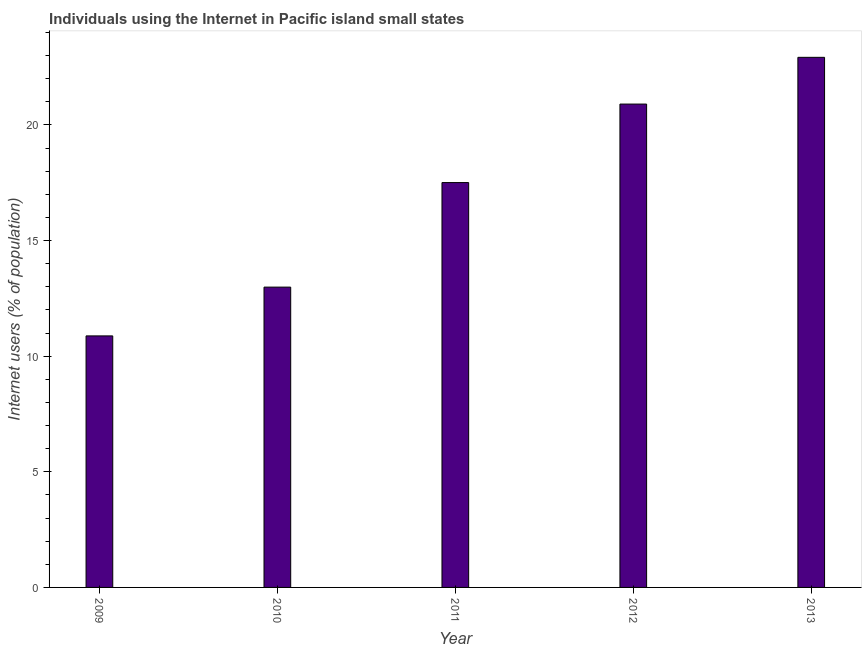Does the graph contain any zero values?
Make the answer very short. No. Does the graph contain grids?
Your response must be concise. No. What is the title of the graph?
Your answer should be very brief. Individuals using the Internet in Pacific island small states. What is the label or title of the X-axis?
Offer a terse response. Year. What is the label or title of the Y-axis?
Make the answer very short. Internet users (% of population). What is the number of internet users in 2009?
Provide a succinct answer. 10.88. Across all years, what is the maximum number of internet users?
Offer a terse response. 22.92. Across all years, what is the minimum number of internet users?
Ensure brevity in your answer.  10.88. What is the sum of the number of internet users?
Give a very brief answer. 85.2. What is the difference between the number of internet users in 2010 and 2012?
Ensure brevity in your answer.  -7.92. What is the average number of internet users per year?
Your response must be concise. 17.04. What is the median number of internet users?
Your answer should be compact. 17.51. Do a majority of the years between 2013 and 2012 (inclusive) have number of internet users greater than 1 %?
Ensure brevity in your answer.  No. What is the ratio of the number of internet users in 2010 to that in 2011?
Give a very brief answer. 0.74. Is the difference between the number of internet users in 2010 and 2013 greater than the difference between any two years?
Your response must be concise. No. What is the difference between the highest and the second highest number of internet users?
Offer a very short reply. 2.02. Is the sum of the number of internet users in 2010 and 2012 greater than the maximum number of internet users across all years?
Give a very brief answer. Yes. What is the difference between the highest and the lowest number of internet users?
Your answer should be very brief. 12.05. In how many years, is the number of internet users greater than the average number of internet users taken over all years?
Offer a very short reply. 3. How many bars are there?
Make the answer very short. 5. Are all the bars in the graph horizontal?
Provide a succinct answer. No. What is the difference between two consecutive major ticks on the Y-axis?
Offer a very short reply. 5. What is the Internet users (% of population) of 2009?
Your answer should be compact. 10.88. What is the Internet users (% of population) of 2010?
Offer a terse response. 12.99. What is the Internet users (% of population) of 2011?
Your answer should be compact. 17.51. What is the Internet users (% of population) of 2012?
Keep it short and to the point. 20.9. What is the Internet users (% of population) of 2013?
Provide a succinct answer. 22.92. What is the difference between the Internet users (% of population) in 2009 and 2010?
Offer a terse response. -2.11. What is the difference between the Internet users (% of population) in 2009 and 2011?
Your response must be concise. -6.63. What is the difference between the Internet users (% of population) in 2009 and 2012?
Offer a very short reply. -10.03. What is the difference between the Internet users (% of population) in 2009 and 2013?
Ensure brevity in your answer.  -12.05. What is the difference between the Internet users (% of population) in 2010 and 2011?
Provide a short and direct response. -4.52. What is the difference between the Internet users (% of population) in 2010 and 2012?
Your answer should be very brief. -7.92. What is the difference between the Internet users (% of population) in 2010 and 2013?
Offer a very short reply. -9.94. What is the difference between the Internet users (% of population) in 2011 and 2012?
Your response must be concise. -3.39. What is the difference between the Internet users (% of population) in 2011 and 2013?
Ensure brevity in your answer.  -5.42. What is the difference between the Internet users (% of population) in 2012 and 2013?
Your answer should be very brief. -2.02. What is the ratio of the Internet users (% of population) in 2009 to that in 2010?
Your response must be concise. 0.84. What is the ratio of the Internet users (% of population) in 2009 to that in 2011?
Provide a succinct answer. 0.62. What is the ratio of the Internet users (% of population) in 2009 to that in 2012?
Your response must be concise. 0.52. What is the ratio of the Internet users (% of population) in 2009 to that in 2013?
Offer a very short reply. 0.47. What is the ratio of the Internet users (% of population) in 2010 to that in 2011?
Your answer should be compact. 0.74. What is the ratio of the Internet users (% of population) in 2010 to that in 2012?
Offer a very short reply. 0.62. What is the ratio of the Internet users (% of population) in 2010 to that in 2013?
Make the answer very short. 0.57. What is the ratio of the Internet users (% of population) in 2011 to that in 2012?
Your response must be concise. 0.84. What is the ratio of the Internet users (% of population) in 2011 to that in 2013?
Give a very brief answer. 0.76. What is the ratio of the Internet users (% of population) in 2012 to that in 2013?
Your answer should be compact. 0.91. 